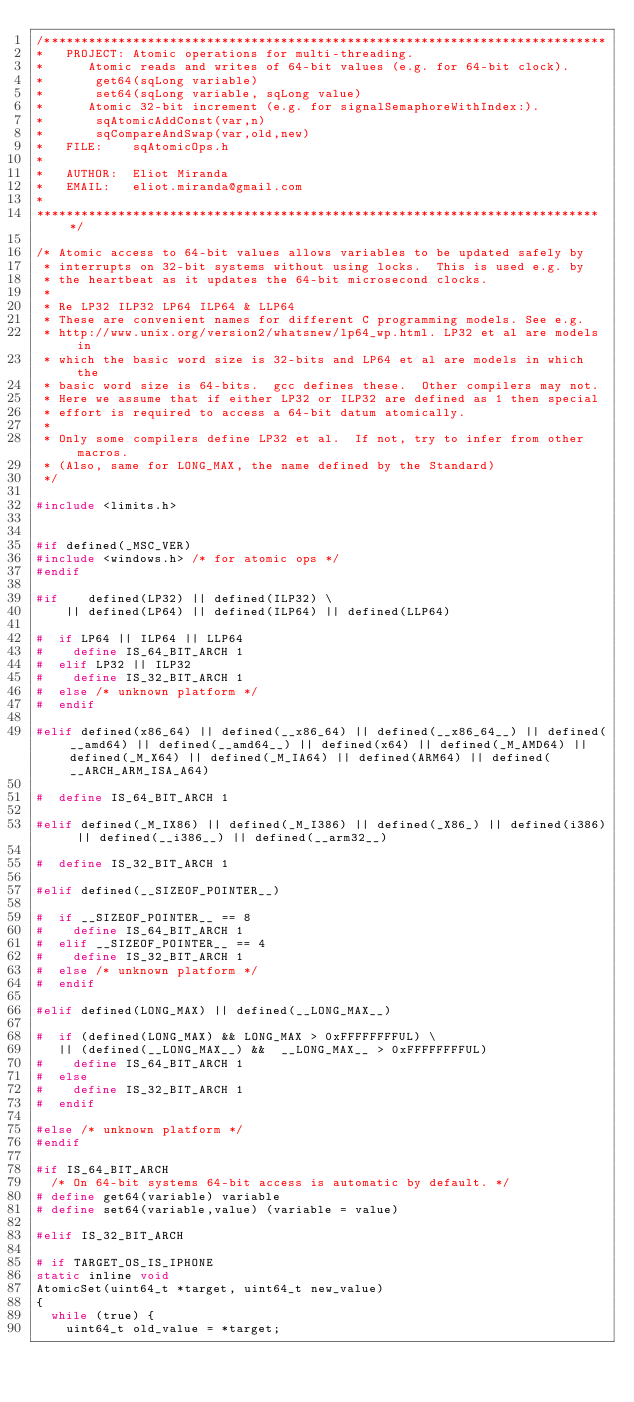Convert code to text. <code><loc_0><loc_0><loc_500><loc_500><_C_>/****************************************************************************
*   PROJECT: Atomic operations for multi-threading.
*			 Atomic reads and writes of 64-bit values (e.g. for 64-bit clock).
*				get64(sqLong variable)
*				set64(sqLong variable, sqLong value)
*			 Atomic 32-bit increment (e.g. for signalSemaphoreWithIndex:).
*				sqAtomicAddConst(var,n)
*				sqCompareAndSwap(var,old,new)
*   FILE:    sqAtomicOps.h
*
*   AUTHOR:  Eliot Miranda
*   EMAIL:   eliot.miranda@gmail.com
*
*****************************************************************************/

/* Atomic access to 64-bit values allows variables to be updated safely by
 * interrupts on 32-bit systems without using locks.  This is used e.g. by
 * the heartbeat as it updates the 64-bit microsecond clocks.
 *
 * Re LP32 ILP32 LP64 ILP64 & LLP64
 * These are convenient names for different C programming models. See e.g.
 * http://www.unix.org/version2/whatsnew/lp64_wp.html. LP32 et al are models in
 * which the basic word size is 32-bits and LP64 et al are models in which the
 * basic word size is 64-bits.  gcc defines these.  Other compilers may not.
 * Here we assume that if either LP32 or ILP32 are defined as 1 then special
 * effort is required to access a 64-bit datum atomically.
 *
 * Only some compilers define LP32 et al.  If not, try to infer from other macros.
 * (Also, same for LONG_MAX, the name defined by the Standard)
 */

#include <limits.h>


#if defined(_MSC_VER)
#include <windows.h> /* for atomic ops */
#endif	

#if    defined(LP32) || defined(ILP32) \
    || defined(LP64) || defined(ILP64) || defined(LLP64)

#  if LP64 || ILP64 || LLP64
#    define IS_64_BIT_ARCH 1
#  elif LP32 || ILP32
#    define IS_32_BIT_ARCH 1
#  else /* unknown platform */
#  endif

#elif defined(x86_64) || defined(__x86_64) || defined(__x86_64__) || defined(__amd64) || defined(__amd64__) || defined(x64) || defined(_M_AMD64) || defined(_M_X64) || defined(_M_IA64) || defined(ARM64) || defined(__ARCH_ARM_ISA_A64)

#  define IS_64_BIT_ARCH 1

#elif defined(_M_IX86) || defined(_M_I386) || defined(_X86_) || defined(i386) || defined(__i386__) || defined(__arm32__)

#  define IS_32_BIT_ARCH 1

#elif defined(__SIZEOF_POINTER__)

#  if __SIZEOF_POINTER__ == 8
#    define IS_64_BIT_ARCH 1
#  elif __SIZEOF_POINTER__ == 4
#    define IS_32_BIT_ARCH 1
#  else /* unknown platform */
#  endif

#elif defined(LONG_MAX) || defined(__LONG_MAX__)

#  if (defined(LONG_MAX) && LONG_MAX > 0xFFFFFFFFUL) \
   || (defined(__LONG_MAX__) &&  __LONG_MAX__ > 0xFFFFFFFFUL)
#    define IS_64_BIT_ARCH 1
#  else
#    define IS_32_BIT_ARCH 1
#  endif

#else /* unknown platform */
#endif

#if IS_64_BIT_ARCH
	/* On 64-bit systems 64-bit access is automatic by default. */
# define get64(variable) variable
# define set64(variable,value) (variable = value)

#elif IS_32_BIT_ARCH

# if TARGET_OS_IS_IPHONE
static inline void
AtomicSet(uint64_t *target, uint64_t new_value)
{
	while (true) {
		uint64_t old_value = *target;</code> 